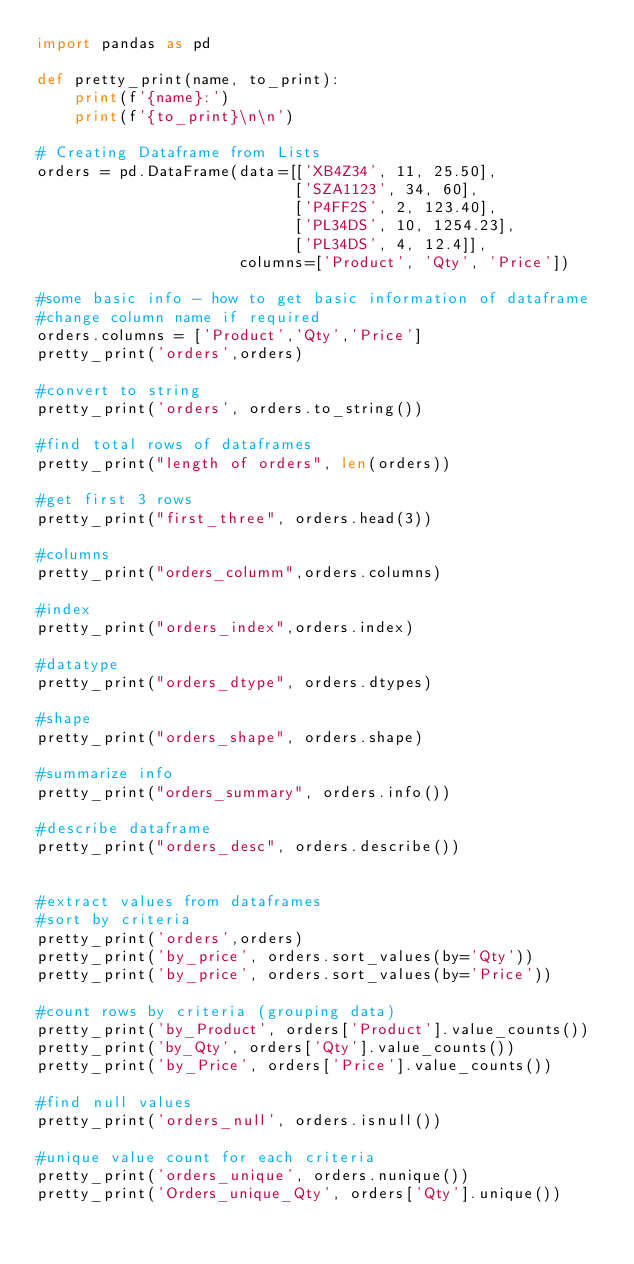Convert code to text. <code><loc_0><loc_0><loc_500><loc_500><_Python_>import pandas as pd

def pretty_print(name, to_print):
    print(f'{name}:')
    print(f'{to_print}\n\n')

# Creating Dataframe from Lists
orders = pd.DataFrame(data=[['XB4Z34', 11, 25.50],
                            ['SZA1123', 34, 60],
                            ['P4FF2S', 2, 123.40],
                            ['PL34DS', 10, 1254.23],
                            ['PL34DS', 4, 12.4]],
                      columns=['Product', 'Qty', 'Price'])

#some basic info - how to get basic information of dataframe
#change column name if required
orders.columns = ['Product','Qty','Price']
pretty_print('orders',orders)

#convert to string
pretty_print('orders', orders.to_string())

#find total rows of dataframes
pretty_print("length of orders", len(orders))

#get first 3 rows
pretty_print("first_three", orders.head(3))

#columns
pretty_print("orders_columm",orders.columns)

#index
pretty_print("orders_index",orders.index)

#datatype
pretty_print("orders_dtype", orders.dtypes)

#shape
pretty_print("orders_shape", orders.shape)

#summarize info
pretty_print("orders_summary", orders.info())

#describe dataframe
pretty_print("orders_desc", orders.describe())


#extract values from dataframes
#sort by criteria
pretty_print('orders',orders)
pretty_print('by_price', orders.sort_values(by='Qty'))
pretty_print('by_price', orders.sort_values(by='Price'))

#count rows by criteria (grouping data)
pretty_print('by_Product', orders['Product'].value_counts())
pretty_print('by_Qty', orders['Qty'].value_counts())
pretty_print('by_Price', orders['Price'].value_counts())

#find null values
pretty_print('orders_null', orders.isnull())

#unique value count for each criteria
pretty_print('orders_unique', orders.nunique())
pretty_print('Orders_unique_Qty', orders['Qty'].unique())
</code> 